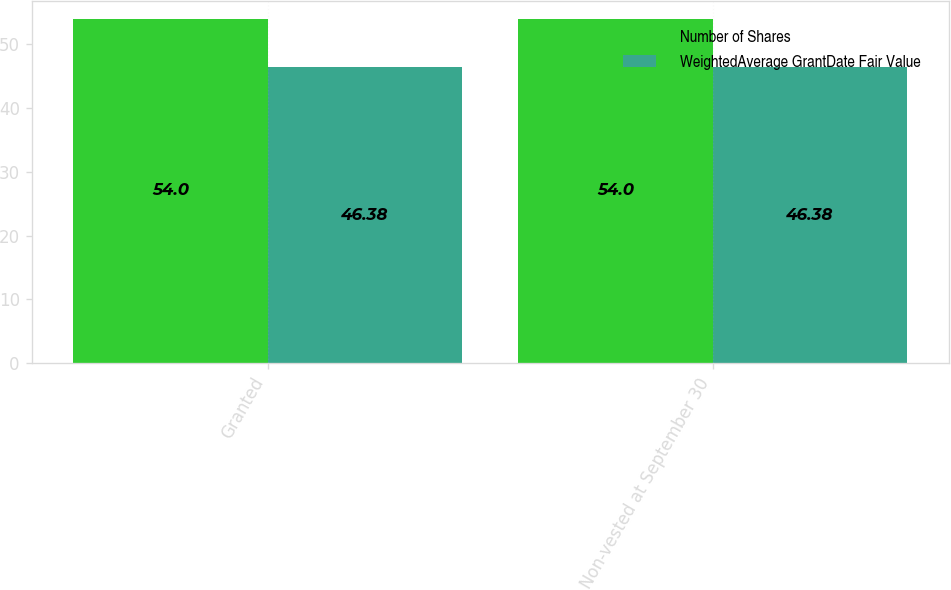Convert chart. <chart><loc_0><loc_0><loc_500><loc_500><stacked_bar_chart><ecel><fcel>Granted<fcel>Non-vested at September 30<nl><fcel>Number of Shares<fcel>54<fcel>54<nl><fcel>WeightedAverage GrantDate Fair Value<fcel>46.38<fcel>46.38<nl></chart> 